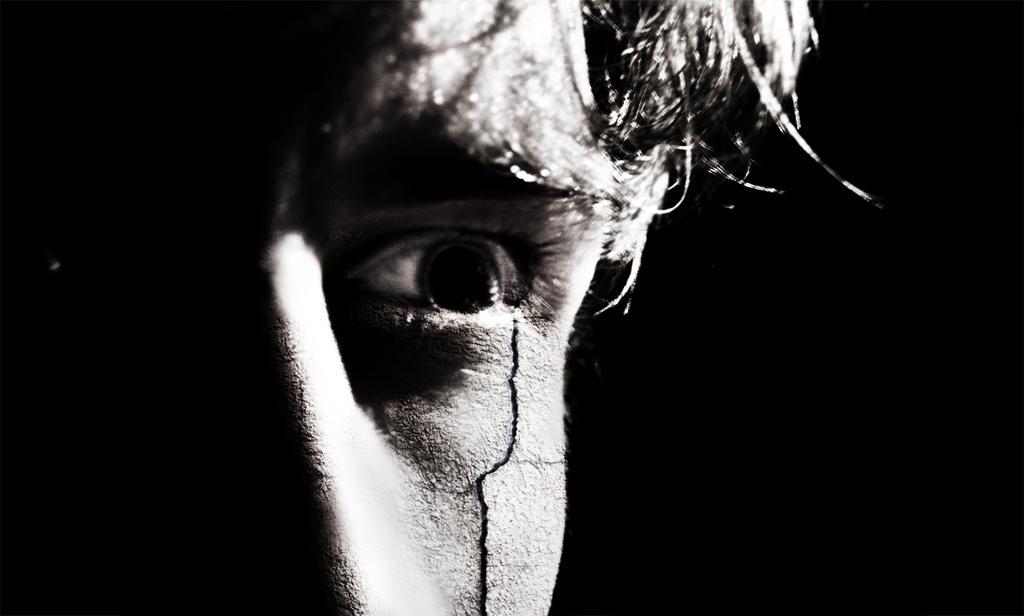In one or two sentences, can you explain what this image depicts? It is the black and white image in which we can see the face of a man. There is a small crack near his eye. 